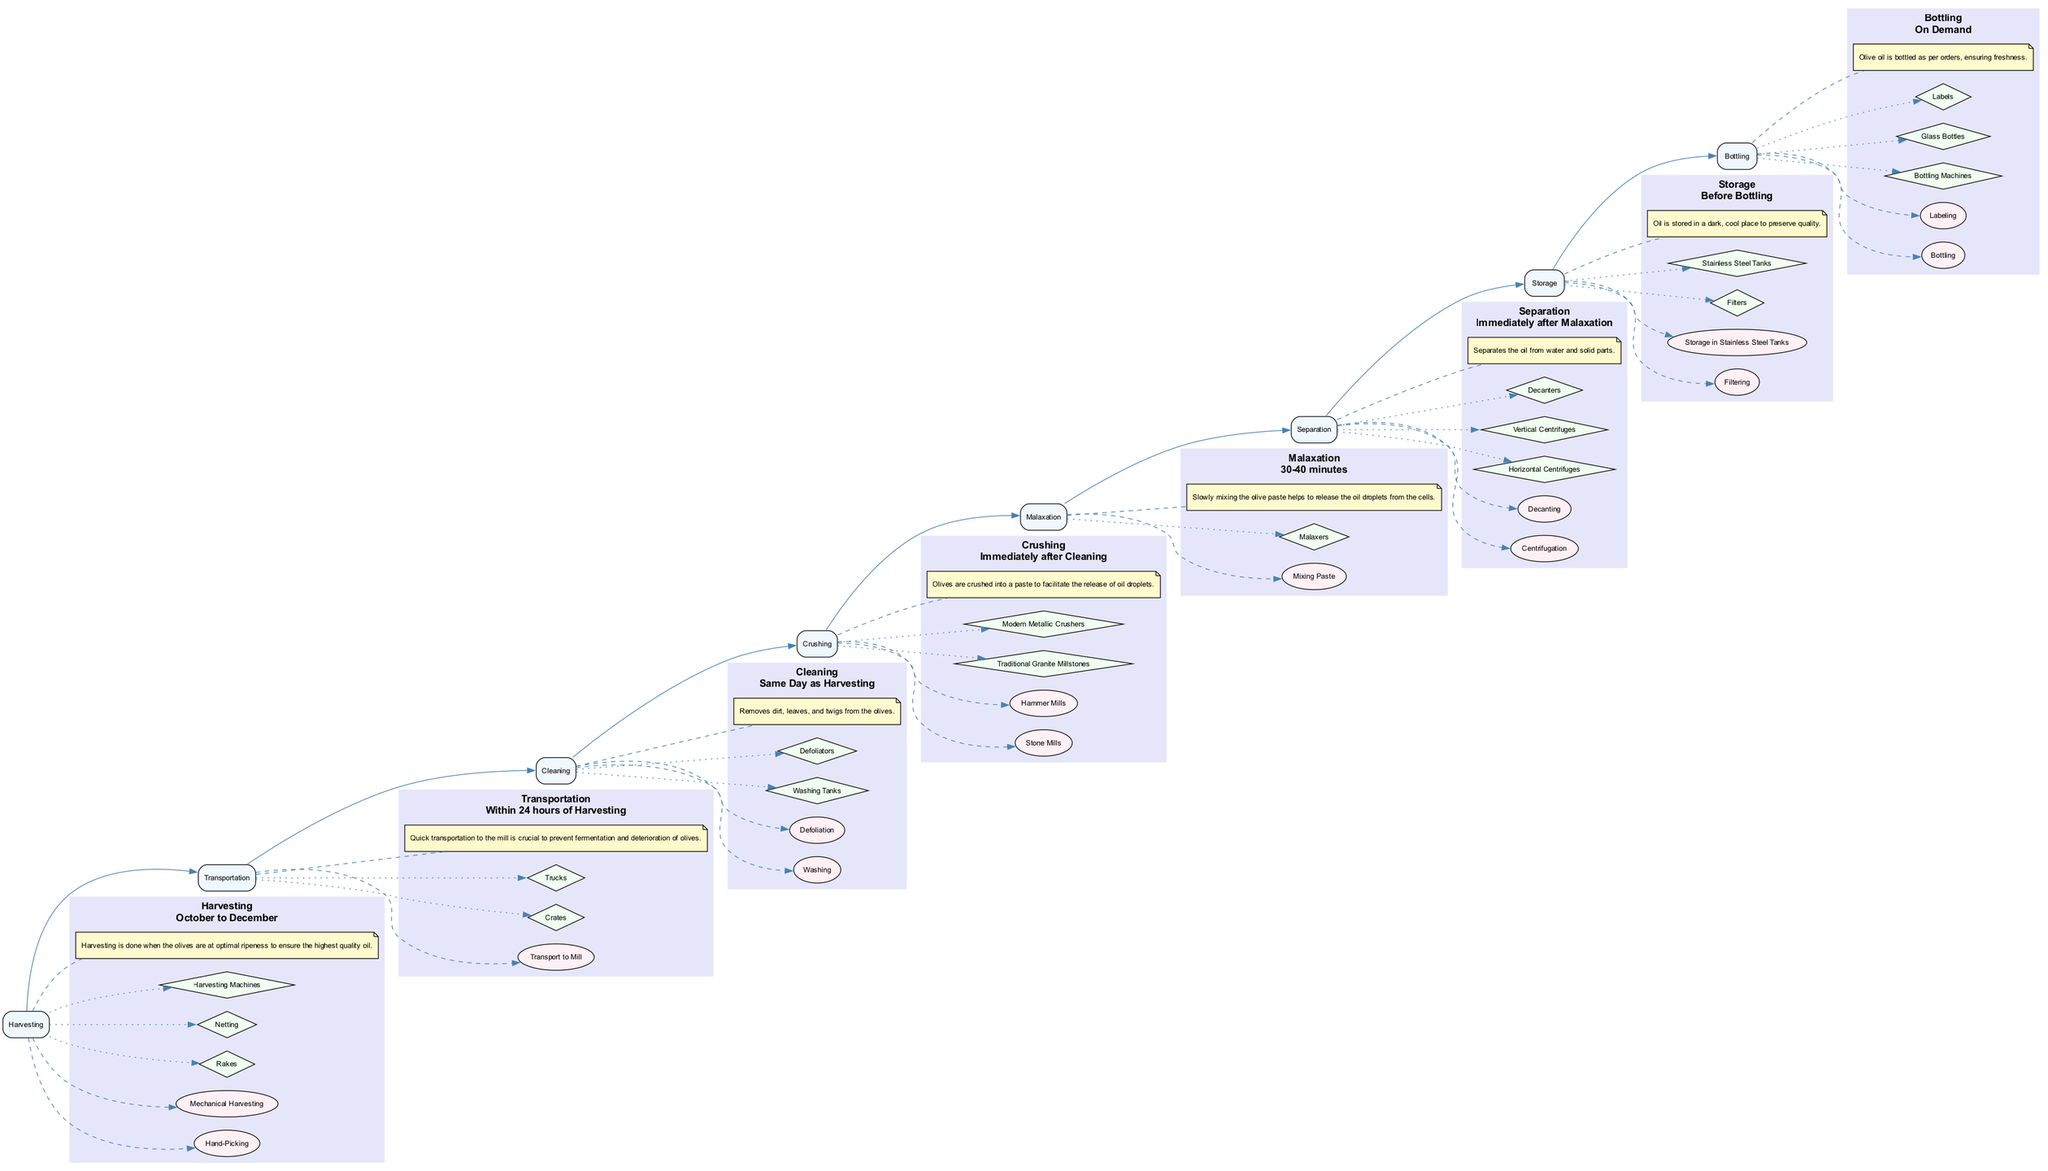What is the timeframe for harvesting? The diagram indicates that harvesting occurs from October to December. This information can be found in the section detailing the harvesting phase of olive oil production.
Answer: October to December What is the first step in the olive oil production process? Upon reviewing the flow of the diagram, the initial process mentioned is harvesting. This is confirmed as it is the first node in the sequence of the diagram.
Answer: Harvesting How many steps are involved in the cleaning process? The cleaning phase of oil production consists of two steps: washing and defoliation. This can be observed in the relevant section of the diagram where the steps are listed.
Answer: 2 Which tools are used in the crushing phase? Looking at the crushing section of the diagram, the tools listed are traditional granite millstones and modern metallic crushers. These are specifically mentioned alongside other details in that segment.
Answer: Traditional granite millstones, modern metallic crushers What is the purpose of malaxation? The diagram notes that malaxation involves slowly mixing the olive paste to help release oil droplets from the cells. This purpose is explicitly outlined in the notes associated with this step in the diagram.
Answer: Release oil droplets from the cells What occurs within 24 hours of harvesting? The diagram states that transport to the mill takes place within 24 hours of harvesting. This crucial timing is highlighted in the transportation section, emphasizing its importance to the process.
Answer: Transport to the mill Which process immediately follows cleaning? Inspecting the flow of the diagram, it indicates that crushing occurs immediately after cleaning. This can be easily traced from the cleaning node to the next step in the production process.
Answer: Crushing What type of facility is used for storage? The storage phase specifies that a temperature-controlled storage facility is used. This detail is clearly outlined in the storage segment of the diagram.
Answer: Temperature-controlled storage facility How long does malaxation last? According to the diagram, malaxation takes 30 to 40 minutes. This timeframe is explicitly mentioned in the timeframe label of the malaxation section.
Answer: 30-40 minutes 